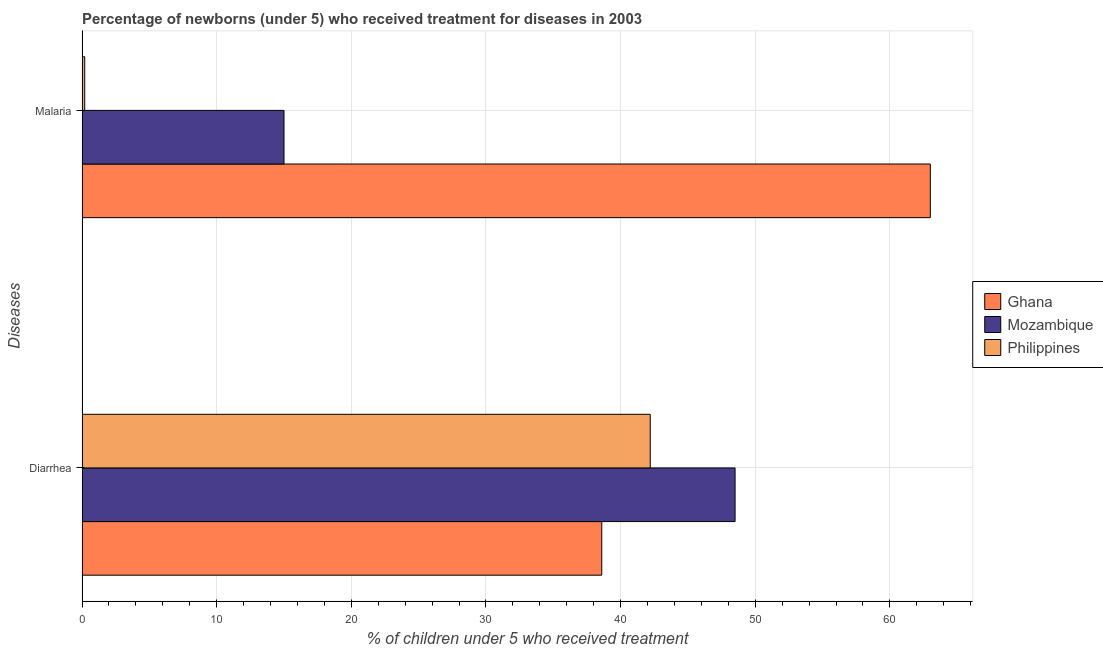How many different coloured bars are there?
Provide a short and direct response. 3. How many groups of bars are there?
Make the answer very short. 2. Are the number of bars per tick equal to the number of legend labels?
Keep it short and to the point. Yes. Are the number of bars on each tick of the Y-axis equal?
Offer a terse response. Yes. How many bars are there on the 1st tick from the bottom?
Provide a short and direct response. 3. What is the label of the 2nd group of bars from the top?
Give a very brief answer. Diarrhea. What is the percentage of children who received treatment for diarrhoea in Philippines?
Make the answer very short. 42.2. Across all countries, what is the maximum percentage of children who received treatment for diarrhoea?
Ensure brevity in your answer.  48.5. Across all countries, what is the minimum percentage of children who received treatment for diarrhoea?
Make the answer very short. 38.6. In which country was the percentage of children who received treatment for diarrhoea maximum?
Ensure brevity in your answer.  Mozambique. In which country was the percentage of children who received treatment for diarrhoea minimum?
Provide a short and direct response. Ghana. What is the total percentage of children who received treatment for diarrhoea in the graph?
Your answer should be compact. 129.3. What is the difference between the percentage of children who received treatment for malaria in Mozambique and that in Ghana?
Your answer should be compact. -48. What is the average percentage of children who received treatment for malaria per country?
Your response must be concise. 26.07. What is the difference between the percentage of children who received treatment for malaria and percentage of children who received treatment for diarrhoea in Ghana?
Your response must be concise. 24.4. What is the ratio of the percentage of children who received treatment for malaria in Ghana to that in Philippines?
Provide a short and direct response. 315. Is the percentage of children who received treatment for malaria in Philippines less than that in Ghana?
Offer a very short reply. Yes. What does the 2nd bar from the top in Diarrhea represents?
Provide a succinct answer. Mozambique. What does the 2nd bar from the bottom in Malaria represents?
Provide a succinct answer. Mozambique. How many bars are there?
Your response must be concise. 6. How many countries are there in the graph?
Give a very brief answer. 3. What is the difference between two consecutive major ticks on the X-axis?
Make the answer very short. 10. Does the graph contain any zero values?
Make the answer very short. No. Does the graph contain grids?
Your answer should be very brief. Yes. Where does the legend appear in the graph?
Make the answer very short. Center right. How many legend labels are there?
Your answer should be compact. 3. How are the legend labels stacked?
Provide a succinct answer. Vertical. What is the title of the graph?
Your response must be concise. Percentage of newborns (under 5) who received treatment for diseases in 2003. What is the label or title of the X-axis?
Give a very brief answer. % of children under 5 who received treatment. What is the label or title of the Y-axis?
Make the answer very short. Diseases. What is the % of children under 5 who received treatment of Ghana in Diarrhea?
Keep it short and to the point. 38.6. What is the % of children under 5 who received treatment in Mozambique in Diarrhea?
Provide a succinct answer. 48.5. What is the % of children under 5 who received treatment in Philippines in Diarrhea?
Your answer should be compact. 42.2. What is the % of children under 5 who received treatment in Ghana in Malaria?
Ensure brevity in your answer.  63. What is the % of children under 5 who received treatment in Mozambique in Malaria?
Ensure brevity in your answer.  15. What is the % of children under 5 who received treatment in Philippines in Malaria?
Provide a short and direct response. 0.2. Across all Diseases, what is the maximum % of children under 5 who received treatment of Ghana?
Make the answer very short. 63. Across all Diseases, what is the maximum % of children under 5 who received treatment of Mozambique?
Give a very brief answer. 48.5. Across all Diseases, what is the maximum % of children under 5 who received treatment in Philippines?
Provide a short and direct response. 42.2. Across all Diseases, what is the minimum % of children under 5 who received treatment in Ghana?
Keep it short and to the point. 38.6. What is the total % of children under 5 who received treatment of Ghana in the graph?
Offer a very short reply. 101.6. What is the total % of children under 5 who received treatment of Mozambique in the graph?
Your answer should be compact. 63.5. What is the total % of children under 5 who received treatment in Philippines in the graph?
Keep it short and to the point. 42.4. What is the difference between the % of children under 5 who received treatment in Ghana in Diarrhea and that in Malaria?
Your answer should be very brief. -24.4. What is the difference between the % of children under 5 who received treatment in Mozambique in Diarrhea and that in Malaria?
Ensure brevity in your answer.  33.5. What is the difference between the % of children under 5 who received treatment of Philippines in Diarrhea and that in Malaria?
Keep it short and to the point. 42. What is the difference between the % of children under 5 who received treatment of Ghana in Diarrhea and the % of children under 5 who received treatment of Mozambique in Malaria?
Your answer should be very brief. 23.6. What is the difference between the % of children under 5 who received treatment of Ghana in Diarrhea and the % of children under 5 who received treatment of Philippines in Malaria?
Provide a short and direct response. 38.4. What is the difference between the % of children under 5 who received treatment of Mozambique in Diarrhea and the % of children under 5 who received treatment of Philippines in Malaria?
Keep it short and to the point. 48.3. What is the average % of children under 5 who received treatment in Ghana per Diseases?
Provide a succinct answer. 50.8. What is the average % of children under 5 who received treatment of Mozambique per Diseases?
Your answer should be very brief. 31.75. What is the average % of children under 5 who received treatment of Philippines per Diseases?
Keep it short and to the point. 21.2. What is the difference between the % of children under 5 who received treatment in Ghana and % of children under 5 who received treatment in Philippines in Diarrhea?
Keep it short and to the point. -3.6. What is the difference between the % of children under 5 who received treatment in Mozambique and % of children under 5 who received treatment in Philippines in Diarrhea?
Your answer should be compact. 6.3. What is the difference between the % of children under 5 who received treatment in Ghana and % of children under 5 who received treatment in Philippines in Malaria?
Your answer should be compact. 62.8. What is the ratio of the % of children under 5 who received treatment of Ghana in Diarrhea to that in Malaria?
Your response must be concise. 0.61. What is the ratio of the % of children under 5 who received treatment in Mozambique in Diarrhea to that in Malaria?
Your answer should be compact. 3.23. What is the ratio of the % of children under 5 who received treatment in Philippines in Diarrhea to that in Malaria?
Keep it short and to the point. 211. What is the difference between the highest and the second highest % of children under 5 who received treatment in Ghana?
Make the answer very short. 24.4. What is the difference between the highest and the second highest % of children under 5 who received treatment of Mozambique?
Make the answer very short. 33.5. What is the difference between the highest and the lowest % of children under 5 who received treatment in Ghana?
Your answer should be very brief. 24.4. What is the difference between the highest and the lowest % of children under 5 who received treatment in Mozambique?
Offer a terse response. 33.5. What is the difference between the highest and the lowest % of children under 5 who received treatment of Philippines?
Provide a short and direct response. 42. 